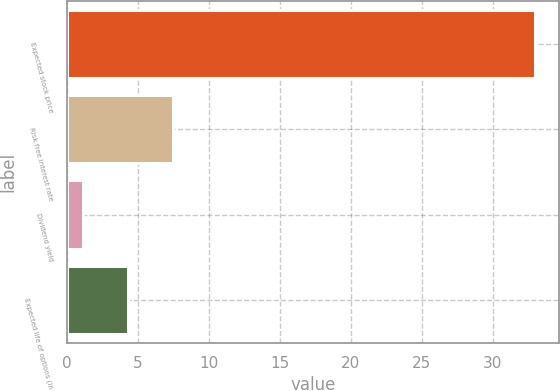Convert chart. <chart><loc_0><loc_0><loc_500><loc_500><bar_chart><fcel>Expected stock price<fcel>Risk free interest rate<fcel>Dividend yield<fcel>Expected life of options (in<nl><fcel>33<fcel>7.48<fcel>1.1<fcel>4.29<nl></chart> 